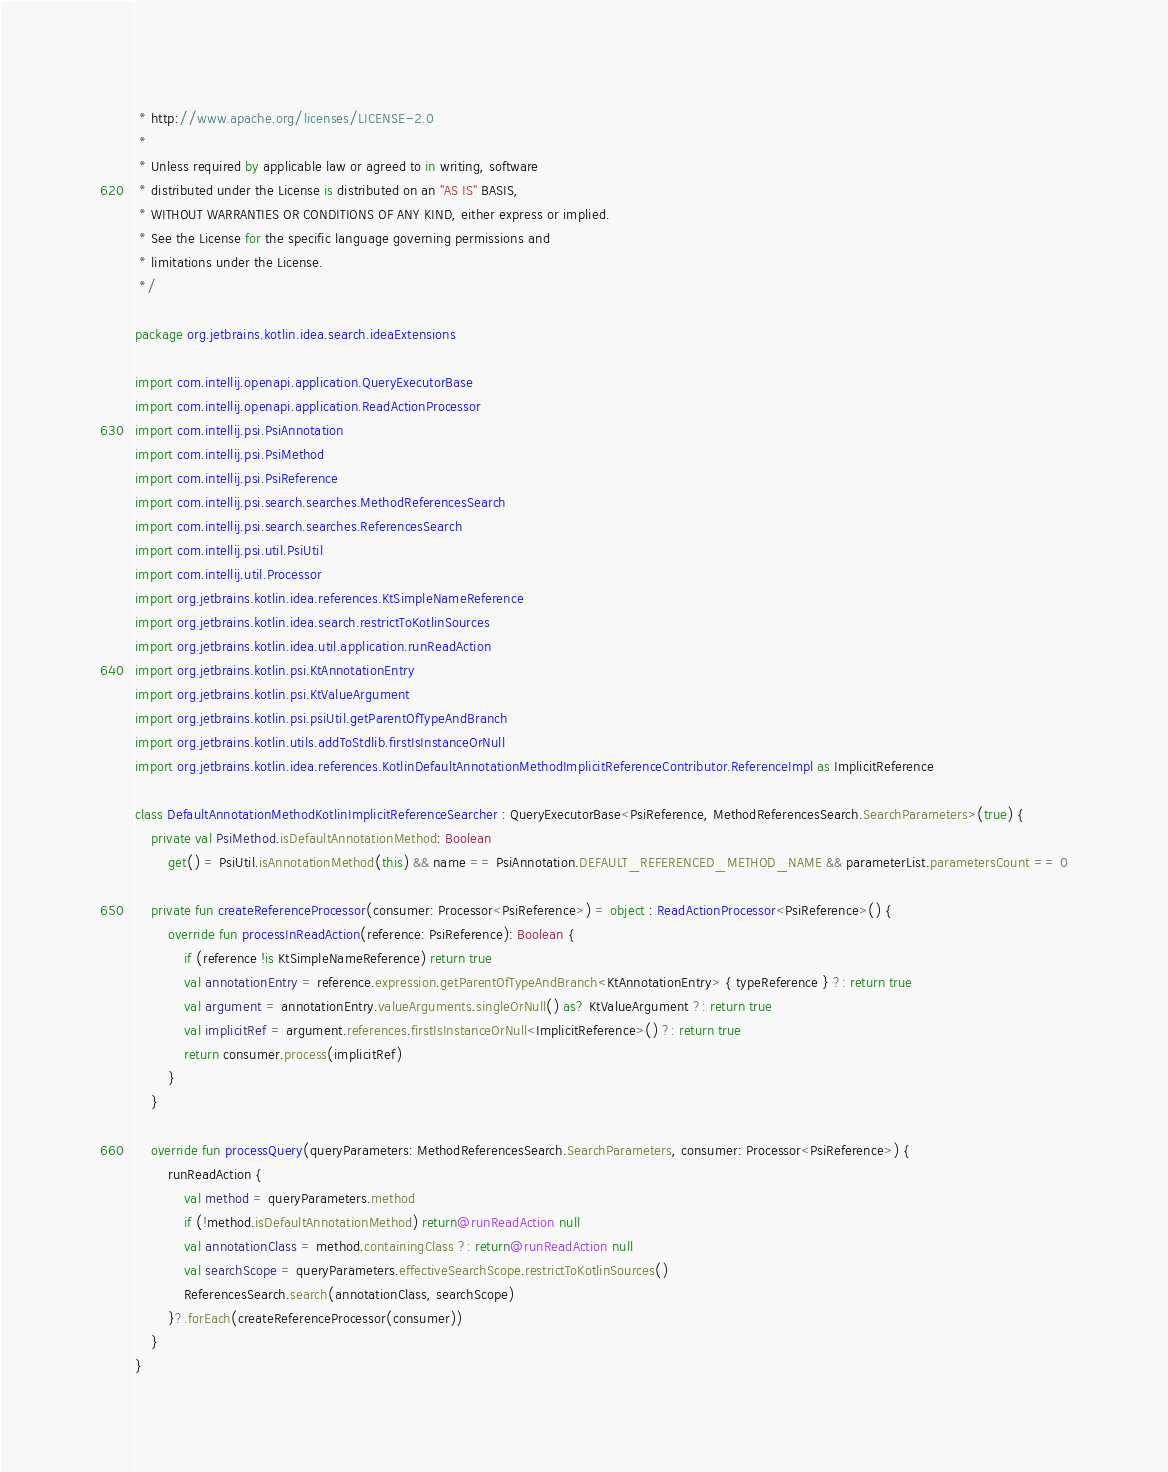Convert code to text. <code><loc_0><loc_0><loc_500><loc_500><_Kotlin_> * http://www.apache.org/licenses/LICENSE-2.0
 *
 * Unless required by applicable law or agreed to in writing, software
 * distributed under the License is distributed on an "AS IS" BASIS,
 * WITHOUT WARRANTIES OR CONDITIONS OF ANY KIND, either express or implied.
 * See the License for the specific language governing permissions and
 * limitations under the License.
 */

package org.jetbrains.kotlin.idea.search.ideaExtensions

import com.intellij.openapi.application.QueryExecutorBase
import com.intellij.openapi.application.ReadActionProcessor
import com.intellij.psi.PsiAnnotation
import com.intellij.psi.PsiMethod
import com.intellij.psi.PsiReference
import com.intellij.psi.search.searches.MethodReferencesSearch
import com.intellij.psi.search.searches.ReferencesSearch
import com.intellij.psi.util.PsiUtil
import com.intellij.util.Processor
import org.jetbrains.kotlin.idea.references.KtSimpleNameReference
import org.jetbrains.kotlin.idea.search.restrictToKotlinSources
import org.jetbrains.kotlin.idea.util.application.runReadAction
import org.jetbrains.kotlin.psi.KtAnnotationEntry
import org.jetbrains.kotlin.psi.KtValueArgument
import org.jetbrains.kotlin.psi.psiUtil.getParentOfTypeAndBranch
import org.jetbrains.kotlin.utils.addToStdlib.firstIsInstanceOrNull
import org.jetbrains.kotlin.idea.references.KotlinDefaultAnnotationMethodImplicitReferenceContributor.ReferenceImpl as ImplicitReference

class DefaultAnnotationMethodKotlinImplicitReferenceSearcher : QueryExecutorBase<PsiReference, MethodReferencesSearch.SearchParameters>(true) {
    private val PsiMethod.isDefaultAnnotationMethod: Boolean
        get() = PsiUtil.isAnnotationMethod(this) && name == PsiAnnotation.DEFAULT_REFERENCED_METHOD_NAME && parameterList.parametersCount == 0

    private fun createReferenceProcessor(consumer: Processor<PsiReference>) = object : ReadActionProcessor<PsiReference>() {
        override fun processInReadAction(reference: PsiReference): Boolean {
            if (reference !is KtSimpleNameReference) return true
            val annotationEntry = reference.expression.getParentOfTypeAndBranch<KtAnnotationEntry> { typeReference } ?: return true
            val argument = annotationEntry.valueArguments.singleOrNull() as? KtValueArgument ?: return true
            val implicitRef = argument.references.firstIsInstanceOrNull<ImplicitReference>() ?: return true
            return consumer.process(implicitRef)
        }
    }

    override fun processQuery(queryParameters: MethodReferencesSearch.SearchParameters, consumer: Processor<PsiReference>) {
        runReadAction {
            val method = queryParameters.method
            if (!method.isDefaultAnnotationMethod) return@runReadAction null
            val annotationClass = method.containingClass ?: return@runReadAction null
            val searchScope = queryParameters.effectiveSearchScope.restrictToKotlinSources()
            ReferencesSearch.search(annotationClass, searchScope)
        }?.forEach(createReferenceProcessor(consumer))
    }
}
</code> 